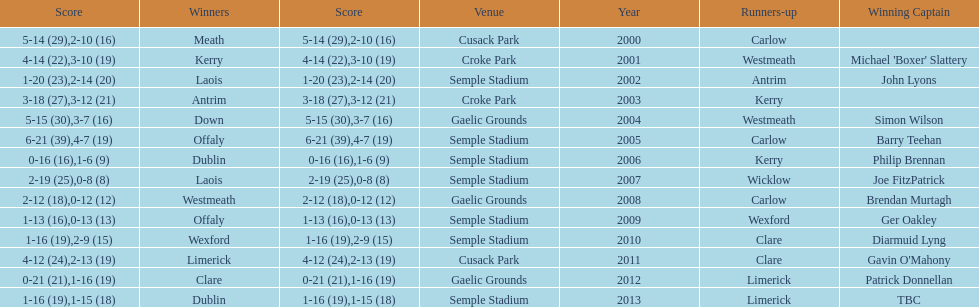Who was the victor post 2007? Laois. 